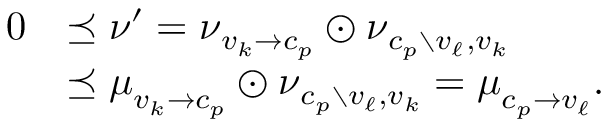Convert formula to latex. <formula><loc_0><loc_0><loc_500><loc_500>\begin{array} { r l } { { 0 } } & { \preceq \nu ^ { \prime } = \nu _ { v _ { k } \to c _ { p } } \odot \nu _ { c _ { p } \ v _ { \ell } , v _ { k } } } \\ & { \preceq \mu _ { v _ { k } \to c _ { p } } \odot \nu _ { c _ { p } \ v _ { \ell } , v _ { k } } = \mu _ { c _ { p } \to v _ { \ell } } . } \end{array}</formula> 